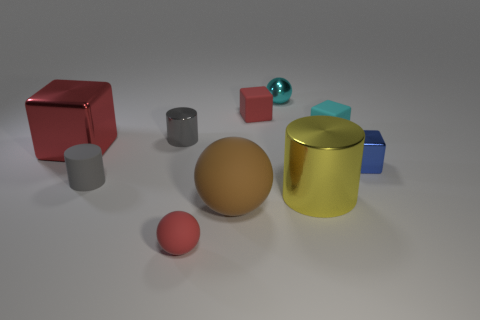Are there any objects that seem out of place in this image? All objects appear intentionally placed, although the blue cube partially hidden behind the golden cylinder might be considered slightly out of place due to it being less visible compared to the others. 